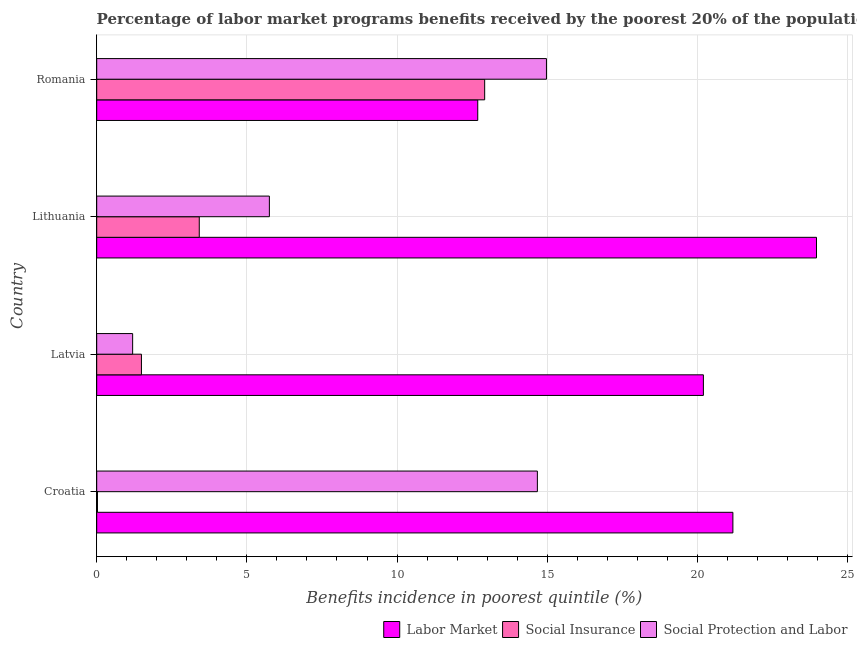How many different coloured bars are there?
Your response must be concise. 3. How many groups of bars are there?
Your response must be concise. 4. Are the number of bars per tick equal to the number of legend labels?
Offer a very short reply. Yes. Are the number of bars on each tick of the Y-axis equal?
Your answer should be very brief. Yes. What is the label of the 2nd group of bars from the top?
Give a very brief answer. Lithuania. What is the percentage of benefits received due to social insurance programs in Croatia?
Your response must be concise. 0.03. Across all countries, what is the maximum percentage of benefits received due to social insurance programs?
Offer a terse response. 12.92. Across all countries, what is the minimum percentage of benefits received due to social protection programs?
Ensure brevity in your answer.  1.2. In which country was the percentage of benefits received due to labor market programs maximum?
Offer a very short reply. Lithuania. In which country was the percentage of benefits received due to labor market programs minimum?
Your answer should be very brief. Romania. What is the total percentage of benefits received due to social protection programs in the graph?
Give a very brief answer. 36.59. What is the difference between the percentage of benefits received due to labor market programs in Croatia and that in Latvia?
Keep it short and to the point. 0.98. What is the difference between the percentage of benefits received due to social insurance programs in Croatia and the percentage of benefits received due to social protection programs in Romania?
Ensure brevity in your answer.  -14.95. What is the average percentage of benefits received due to labor market programs per country?
Your answer should be compact. 19.51. What is the difference between the percentage of benefits received due to labor market programs and percentage of benefits received due to social protection programs in Lithuania?
Make the answer very short. 18.22. In how many countries, is the percentage of benefits received due to social protection programs greater than 14 %?
Your response must be concise. 2. What is the ratio of the percentage of benefits received due to social protection programs in Croatia to that in Latvia?
Make the answer very short. 12.26. Is the percentage of benefits received due to social protection programs in Croatia less than that in Latvia?
Give a very brief answer. No. Is the difference between the percentage of benefits received due to social insurance programs in Croatia and Romania greater than the difference between the percentage of benefits received due to social protection programs in Croatia and Romania?
Offer a very short reply. No. What is the difference between the highest and the second highest percentage of benefits received due to social insurance programs?
Offer a very short reply. 9.5. What is the difference between the highest and the lowest percentage of benefits received due to social insurance programs?
Provide a succinct answer. 12.89. What does the 1st bar from the top in Latvia represents?
Make the answer very short. Social Protection and Labor. What does the 3rd bar from the bottom in Latvia represents?
Give a very brief answer. Social Protection and Labor. Is it the case that in every country, the sum of the percentage of benefits received due to labor market programs and percentage of benefits received due to social insurance programs is greater than the percentage of benefits received due to social protection programs?
Provide a succinct answer. Yes. How many bars are there?
Provide a short and direct response. 12. Are all the bars in the graph horizontal?
Provide a succinct answer. Yes. How many legend labels are there?
Offer a very short reply. 3. What is the title of the graph?
Make the answer very short. Percentage of labor market programs benefits received by the poorest 20% of the population of countries. Does "Ireland" appear as one of the legend labels in the graph?
Your answer should be compact. No. What is the label or title of the X-axis?
Give a very brief answer. Benefits incidence in poorest quintile (%). What is the label or title of the Y-axis?
Provide a short and direct response. Country. What is the Benefits incidence in poorest quintile (%) in Labor Market in Croatia?
Ensure brevity in your answer.  21.18. What is the Benefits incidence in poorest quintile (%) in Social Insurance in Croatia?
Provide a short and direct response. 0.03. What is the Benefits incidence in poorest quintile (%) in Social Protection and Labor in Croatia?
Provide a short and direct response. 14.67. What is the Benefits incidence in poorest quintile (%) of Labor Market in Latvia?
Keep it short and to the point. 20.2. What is the Benefits incidence in poorest quintile (%) of Social Insurance in Latvia?
Give a very brief answer. 1.49. What is the Benefits incidence in poorest quintile (%) of Social Protection and Labor in Latvia?
Your answer should be compact. 1.2. What is the Benefits incidence in poorest quintile (%) of Labor Market in Lithuania?
Ensure brevity in your answer.  23.97. What is the Benefits incidence in poorest quintile (%) of Social Insurance in Lithuania?
Your response must be concise. 3.41. What is the Benefits incidence in poorest quintile (%) of Social Protection and Labor in Lithuania?
Your response must be concise. 5.75. What is the Benefits incidence in poorest quintile (%) in Labor Market in Romania?
Make the answer very short. 12.69. What is the Benefits incidence in poorest quintile (%) in Social Insurance in Romania?
Ensure brevity in your answer.  12.92. What is the Benefits incidence in poorest quintile (%) in Social Protection and Labor in Romania?
Offer a terse response. 14.98. Across all countries, what is the maximum Benefits incidence in poorest quintile (%) in Labor Market?
Offer a terse response. 23.97. Across all countries, what is the maximum Benefits incidence in poorest quintile (%) in Social Insurance?
Provide a short and direct response. 12.92. Across all countries, what is the maximum Benefits incidence in poorest quintile (%) in Social Protection and Labor?
Keep it short and to the point. 14.98. Across all countries, what is the minimum Benefits incidence in poorest quintile (%) in Labor Market?
Offer a very short reply. 12.69. Across all countries, what is the minimum Benefits incidence in poorest quintile (%) in Social Insurance?
Ensure brevity in your answer.  0.03. Across all countries, what is the minimum Benefits incidence in poorest quintile (%) in Social Protection and Labor?
Your answer should be compact. 1.2. What is the total Benefits incidence in poorest quintile (%) of Labor Market in the graph?
Your answer should be very brief. 78.04. What is the total Benefits incidence in poorest quintile (%) in Social Insurance in the graph?
Give a very brief answer. 17.85. What is the total Benefits incidence in poorest quintile (%) in Social Protection and Labor in the graph?
Provide a short and direct response. 36.59. What is the difference between the Benefits incidence in poorest quintile (%) in Labor Market in Croatia and that in Latvia?
Your answer should be compact. 0.98. What is the difference between the Benefits incidence in poorest quintile (%) of Social Insurance in Croatia and that in Latvia?
Your answer should be very brief. -1.46. What is the difference between the Benefits incidence in poorest quintile (%) of Social Protection and Labor in Croatia and that in Latvia?
Offer a very short reply. 13.48. What is the difference between the Benefits incidence in poorest quintile (%) in Labor Market in Croatia and that in Lithuania?
Your answer should be very brief. -2.78. What is the difference between the Benefits incidence in poorest quintile (%) of Social Insurance in Croatia and that in Lithuania?
Keep it short and to the point. -3.39. What is the difference between the Benefits incidence in poorest quintile (%) of Social Protection and Labor in Croatia and that in Lithuania?
Your answer should be very brief. 8.92. What is the difference between the Benefits incidence in poorest quintile (%) of Labor Market in Croatia and that in Romania?
Keep it short and to the point. 8.5. What is the difference between the Benefits incidence in poorest quintile (%) of Social Insurance in Croatia and that in Romania?
Your response must be concise. -12.89. What is the difference between the Benefits incidence in poorest quintile (%) in Social Protection and Labor in Croatia and that in Romania?
Make the answer very short. -0.3. What is the difference between the Benefits incidence in poorest quintile (%) of Labor Market in Latvia and that in Lithuania?
Keep it short and to the point. -3.77. What is the difference between the Benefits incidence in poorest quintile (%) in Social Insurance in Latvia and that in Lithuania?
Ensure brevity in your answer.  -1.93. What is the difference between the Benefits incidence in poorest quintile (%) of Social Protection and Labor in Latvia and that in Lithuania?
Offer a very short reply. -4.55. What is the difference between the Benefits incidence in poorest quintile (%) of Labor Market in Latvia and that in Romania?
Offer a terse response. 7.51. What is the difference between the Benefits incidence in poorest quintile (%) of Social Insurance in Latvia and that in Romania?
Your response must be concise. -11.43. What is the difference between the Benefits incidence in poorest quintile (%) in Social Protection and Labor in Latvia and that in Romania?
Provide a short and direct response. -13.78. What is the difference between the Benefits incidence in poorest quintile (%) of Labor Market in Lithuania and that in Romania?
Ensure brevity in your answer.  11.28. What is the difference between the Benefits incidence in poorest quintile (%) in Social Insurance in Lithuania and that in Romania?
Ensure brevity in your answer.  -9.5. What is the difference between the Benefits incidence in poorest quintile (%) in Social Protection and Labor in Lithuania and that in Romania?
Your answer should be compact. -9.23. What is the difference between the Benefits incidence in poorest quintile (%) of Labor Market in Croatia and the Benefits incidence in poorest quintile (%) of Social Insurance in Latvia?
Provide a succinct answer. 19.69. What is the difference between the Benefits incidence in poorest quintile (%) in Labor Market in Croatia and the Benefits incidence in poorest quintile (%) in Social Protection and Labor in Latvia?
Make the answer very short. 19.99. What is the difference between the Benefits incidence in poorest quintile (%) of Social Insurance in Croatia and the Benefits incidence in poorest quintile (%) of Social Protection and Labor in Latvia?
Your answer should be very brief. -1.17. What is the difference between the Benefits incidence in poorest quintile (%) in Labor Market in Croatia and the Benefits incidence in poorest quintile (%) in Social Insurance in Lithuania?
Ensure brevity in your answer.  17.77. What is the difference between the Benefits incidence in poorest quintile (%) of Labor Market in Croatia and the Benefits incidence in poorest quintile (%) of Social Protection and Labor in Lithuania?
Keep it short and to the point. 15.43. What is the difference between the Benefits incidence in poorest quintile (%) in Social Insurance in Croatia and the Benefits incidence in poorest quintile (%) in Social Protection and Labor in Lithuania?
Give a very brief answer. -5.72. What is the difference between the Benefits incidence in poorest quintile (%) in Labor Market in Croatia and the Benefits incidence in poorest quintile (%) in Social Insurance in Romania?
Provide a short and direct response. 8.27. What is the difference between the Benefits incidence in poorest quintile (%) of Labor Market in Croatia and the Benefits incidence in poorest quintile (%) of Social Protection and Labor in Romania?
Your answer should be very brief. 6.21. What is the difference between the Benefits incidence in poorest quintile (%) of Social Insurance in Croatia and the Benefits incidence in poorest quintile (%) of Social Protection and Labor in Romania?
Your answer should be very brief. -14.95. What is the difference between the Benefits incidence in poorest quintile (%) in Labor Market in Latvia and the Benefits incidence in poorest quintile (%) in Social Insurance in Lithuania?
Your answer should be very brief. 16.79. What is the difference between the Benefits incidence in poorest quintile (%) in Labor Market in Latvia and the Benefits incidence in poorest quintile (%) in Social Protection and Labor in Lithuania?
Offer a terse response. 14.45. What is the difference between the Benefits incidence in poorest quintile (%) in Social Insurance in Latvia and the Benefits incidence in poorest quintile (%) in Social Protection and Labor in Lithuania?
Offer a very short reply. -4.26. What is the difference between the Benefits incidence in poorest quintile (%) in Labor Market in Latvia and the Benefits incidence in poorest quintile (%) in Social Insurance in Romania?
Keep it short and to the point. 7.28. What is the difference between the Benefits incidence in poorest quintile (%) of Labor Market in Latvia and the Benefits incidence in poorest quintile (%) of Social Protection and Labor in Romania?
Your answer should be compact. 5.23. What is the difference between the Benefits incidence in poorest quintile (%) of Social Insurance in Latvia and the Benefits incidence in poorest quintile (%) of Social Protection and Labor in Romania?
Keep it short and to the point. -13.49. What is the difference between the Benefits incidence in poorest quintile (%) of Labor Market in Lithuania and the Benefits incidence in poorest quintile (%) of Social Insurance in Romania?
Your answer should be very brief. 11.05. What is the difference between the Benefits incidence in poorest quintile (%) in Labor Market in Lithuania and the Benefits incidence in poorest quintile (%) in Social Protection and Labor in Romania?
Provide a short and direct response. 8.99. What is the difference between the Benefits incidence in poorest quintile (%) in Social Insurance in Lithuania and the Benefits incidence in poorest quintile (%) in Social Protection and Labor in Romania?
Provide a short and direct response. -11.56. What is the average Benefits incidence in poorest quintile (%) in Labor Market per country?
Give a very brief answer. 19.51. What is the average Benefits incidence in poorest quintile (%) in Social Insurance per country?
Your response must be concise. 4.46. What is the average Benefits incidence in poorest quintile (%) of Social Protection and Labor per country?
Ensure brevity in your answer.  9.15. What is the difference between the Benefits incidence in poorest quintile (%) in Labor Market and Benefits incidence in poorest quintile (%) in Social Insurance in Croatia?
Provide a succinct answer. 21.16. What is the difference between the Benefits incidence in poorest quintile (%) in Labor Market and Benefits incidence in poorest quintile (%) in Social Protection and Labor in Croatia?
Your answer should be compact. 6.51. What is the difference between the Benefits incidence in poorest quintile (%) in Social Insurance and Benefits incidence in poorest quintile (%) in Social Protection and Labor in Croatia?
Ensure brevity in your answer.  -14.65. What is the difference between the Benefits incidence in poorest quintile (%) in Labor Market and Benefits incidence in poorest quintile (%) in Social Insurance in Latvia?
Offer a terse response. 18.71. What is the difference between the Benefits incidence in poorest quintile (%) in Labor Market and Benefits incidence in poorest quintile (%) in Social Protection and Labor in Latvia?
Ensure brevity in your answer.  19. What is the difference between the Benefits incidence in poorest quintile (%) of Social Insurance and Benefits incidence in poorest quintile (%) of Social Protection and Labor in Latvia?
Your response must be concise. 0.29. What is the difference between the Benefits incidence in poorest quintile (%) of Labor Market and Benefits incidence in poorest quintile (%) of Social Insurance in Lithuania?
Offer a terse response. 20.55. What is the difference between the Benefits incidence in poorest quintile (%) in Labor Market and Benefits incidence in poorest quintile (%) in Social Protection and Labor in Lithuania?
Provide a short and direct response. 18.22. What is the difference between the Benefits incidence in poorest quintile (%) in Social Insurance and Benefits incidence in poorest quintile (%) in Social Protection and Labor in Lithuania?
Provide a succinct answer. -2.33. What is the difference between the Benefits incidence in poorest quintile (%) of Labor Market and Benefits incidence in poorest quintile (%) of Social Insurance in Romania?
Your answer should be very brief. -0.23. What is the difference between the Benefits incidence in poorest quintile (%) of Labor Market and Benefits incidence in poorest quintile (%) of Social Protection and Labor in Romania?
Give a very brief answer. -2.29. What is the difference between the Benefits incidence in poorest quintile (%) of Social Insurance and Benefits incidence in poorest quintile (%) of Social Protection and Labor in Romania?
Provide a short and direct response. -2.06. What is the ratio of the Benefits incidence in poorest quintile (%) in Labor Market in Croatia to that in Latvia?
Provide a short and direct response. 1.05. What is the ratio of the Benefits incidence in poorest quintile (%) of Social Insurance in Croatia to that in Latvia?
Make the answer very short. 0.02. What is the ratio of the Benefits incidence in poorest quintile (%) of Social Protection and Labor in Croatia to that in Latvia?
Provide a succinct answer. 12.26. What is the ratio of the Benefits incidence in poorest quintile (%) in Labor Market in Croatia to that in Lithuania?
Your answer should be very brief. 0.88. What is the ratio of the Benefits incidence in poorest quintile (%) in Social Insurance in Croatia to that in Lithuania?
Provide a succinct answer. 0.01. What is the ratio of the Benefits incidence in poorest quintile (%) of Social Protection and Labor in Croatia to that in Lithuania?
Provide a succinct answer. 2.55. What is the ratio of the Benefits incidence in poorest quintile (%) of Labor Market in Croatia to that in Romania?
Make the answer very short. 1.67. What is the ratio of the Benefits incidence in poorest quintile (%) in Social Insurance in Croatia to that in Romania?
Your answer should be compact. 0. What is the ratio of the Benefits incidence in poorest quintile (%) of Social Protection and Labor in Croatia to that in Romania?
Your response must be concise. 0.98. What is the ratio of the Benefits incidence in poorest quintile (%) in Labor Market in Latvia to that in Lithuania?
Provide a succinct answer. 0.84. What is the ratio of the Benefits incidence in poorest quintile (%) of Social Insurance in Latvia to that in Lithuania?
Your response must be concise. 0.44. What is the ratio of the Benefits incidence in poorest quintile (%) of Social Protection and Labor in Latvia to that in Lithuania?
Provide a succinct answer. 0.21. What is the ratio of the Benefits incidence in poorest quintile (%) of Labor Market in Latvia to that in Romania?
Give a very brief answer. 1.59. What is the ratio of the Benefits incidence in poorest quintile (%) of Social Insurance in Latvia to that in Romania?
Keep it short and to the point. 0.12. What is the ratio of the Benefits incidence in poorest quintile (%) of Social Protection and Labor in Latvia to that in Romania?
Give a very brief answer. 0.08. What is the ratio of the Benefits incidence in poorest quintile (%) in Labor Market in Lithuania to that in Romania?
Your response must be concise. 1.89. What is the ratio of the Benefits incidence in poorest quintile (%) in Social Insurance in Lithuania to that in Romania?
Provide a succinct answer. 0.26. What is the ratio of the Benefits incidence in poorest quintile (%) of Social Protection and Labor in Lithuania to that in Romania?
Give a very brief answer. 0.38. What is the difference between the highest and the second highest Benefits incidence in poorest quintile (%) of Labor Market?
Provide a short and direct response. 2.78. What is the difference between the highest and the second highest Benefits incidence in poorest quintile (%) of Social Insurance?
Keep it short and to the point. 9.5. What is the difference between the highest and the second highest Benefits incidence in poorest quintile (%) of Social Protection and Labor?
Keep it short and to the point. 0.3. What is the difference between the highest and the lowest Benefits incidence in poorest quintile (%) in Labor Market?
Make the answer very short. 11.28. What is the difference between the highest and the lowest Benefits incidence in poorest quintile (%) in Social Insurance?
Ensure brevity in your answer.  12.89. What is the difference between the highest and the lowest Benefits incidence in poorest quintile (%) of Social Protection and Labor?
Make the answer very short. 13.78. 